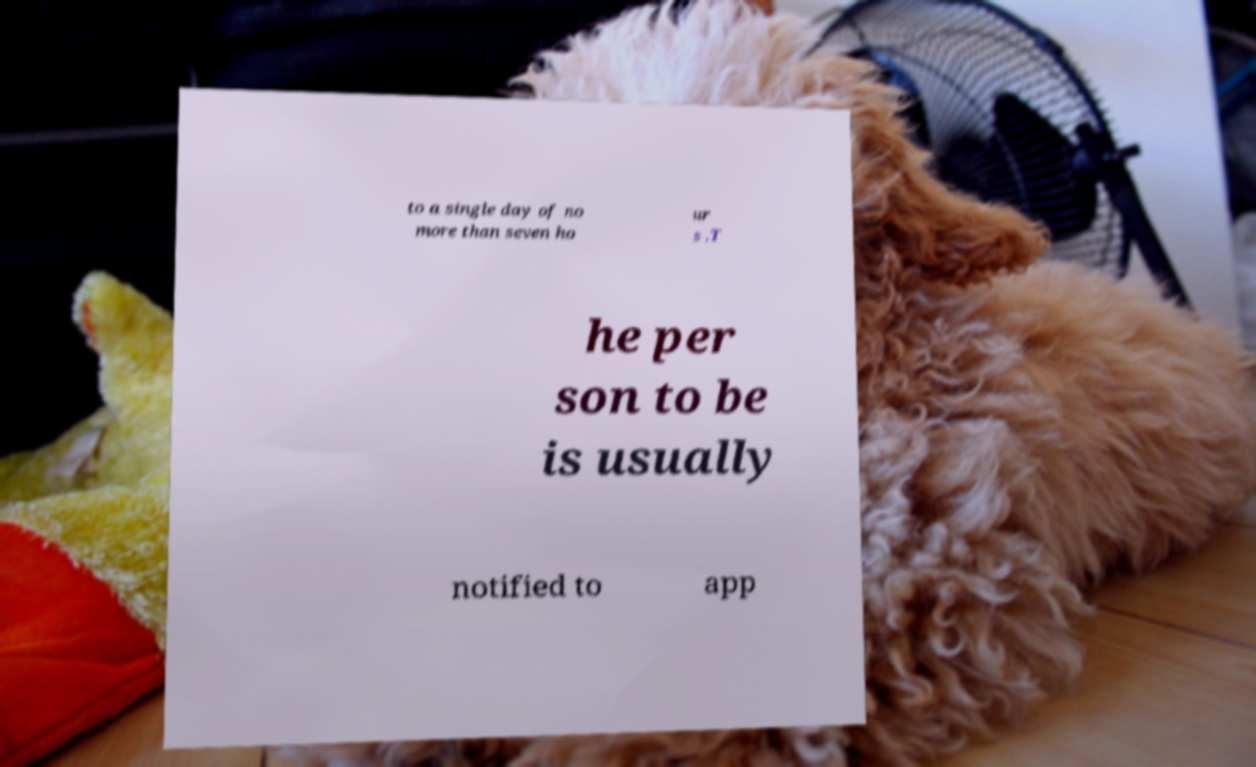Can you read and provide the text displayed in the image?This photo seems to have some interesting text. Can you extract and type it out for me? to a single day of no more than seven ho ur s .T he per son to be is usually notified to app 